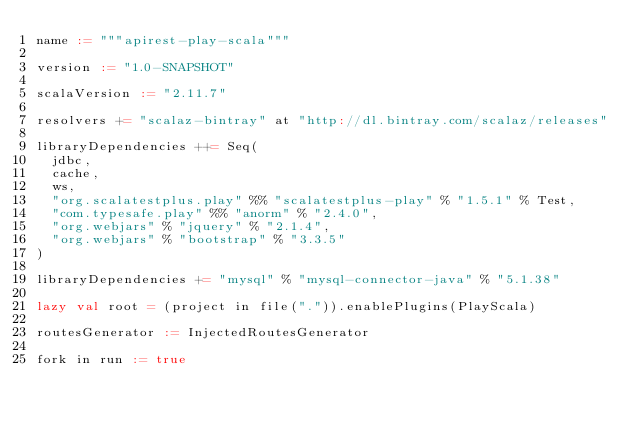<code> <loc_0><loc_0><loc_500><loc_500><_Scala_>name := """apirest-play-scala"""

version := "1.0-SNAPSHOT"

scalaVersion := "2.11.7"

resolvers += "scalaz-bintray" at "http://dl.bintray.com/scalaz/releases"

libraryDependencies ++= Seq(
  jdbc,
  cache,
  ws,
  "org.scalatestplus.play" %% "scalatestplus-play" % "1.5.1" % Test,
  "com.typesafe.play" %% "anorm" % "2.4.0",
  "org.webjars" % "jquery" % "2.1.4",
  "org.webjars" % "bootstrap" % "3.3.5"
)

libraryDependencies += "mysql" % "mysql-connector-java" % "5.1.38"

lazy val root = (project in file(".")).enablePlugins(PlayScala)

routesGenerator := InjectedRoutesGenerator

fork in run := true
</code> 